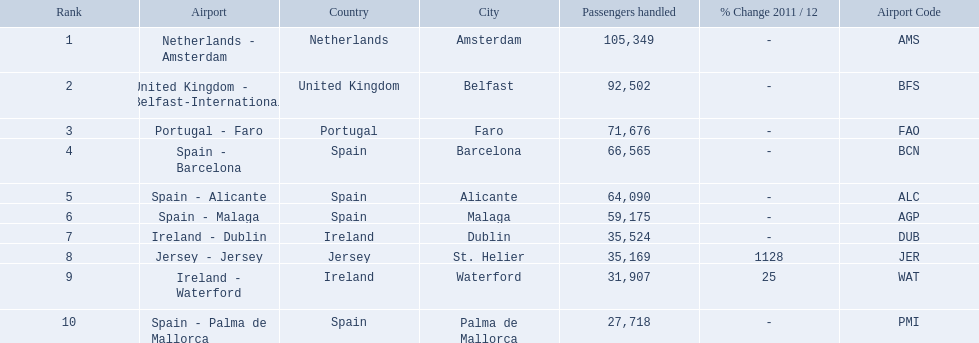What are the numbers of passengers handled along the different routes in the airport? 105,349, 92,502, 71,676, 66,565, 64,090, 59,175, 35,524, 35,169, 31,907, 27,718. Of these routes, which handles less than 30,000 passengers? Spain - Palma de Mallorca. What are all of the airports? Netherlands - Amsterdam, United Kingdom - Belfast-International, Portugal - Faro, Spain - Barcelona, Spain - Alicante, Spain - Malaga, Ireland - Dublin, Jersey - Jersey, Ireland - Waterford, Spain - Palma de Mallorca. How many passengers have they handled? 105,349, 92,502, 71,676, 66,565, 64,090, 59,175, 35,524, 35,169, 31,907, 27,718. And which airport has handled the most passengers? Netherlands - Amsterdam. Which airports are in europe? Netherlands - Amsterdam, United Kingdom - Belfast-International, Portugal - Faro, Spain - Barcelona, Spain - Alicante, Spain - Malaga, Ireland - Dublin, Ireland - Waterford, Spain - Palma de Mallorca. Which one is from portugal? Portugal - Faro. 